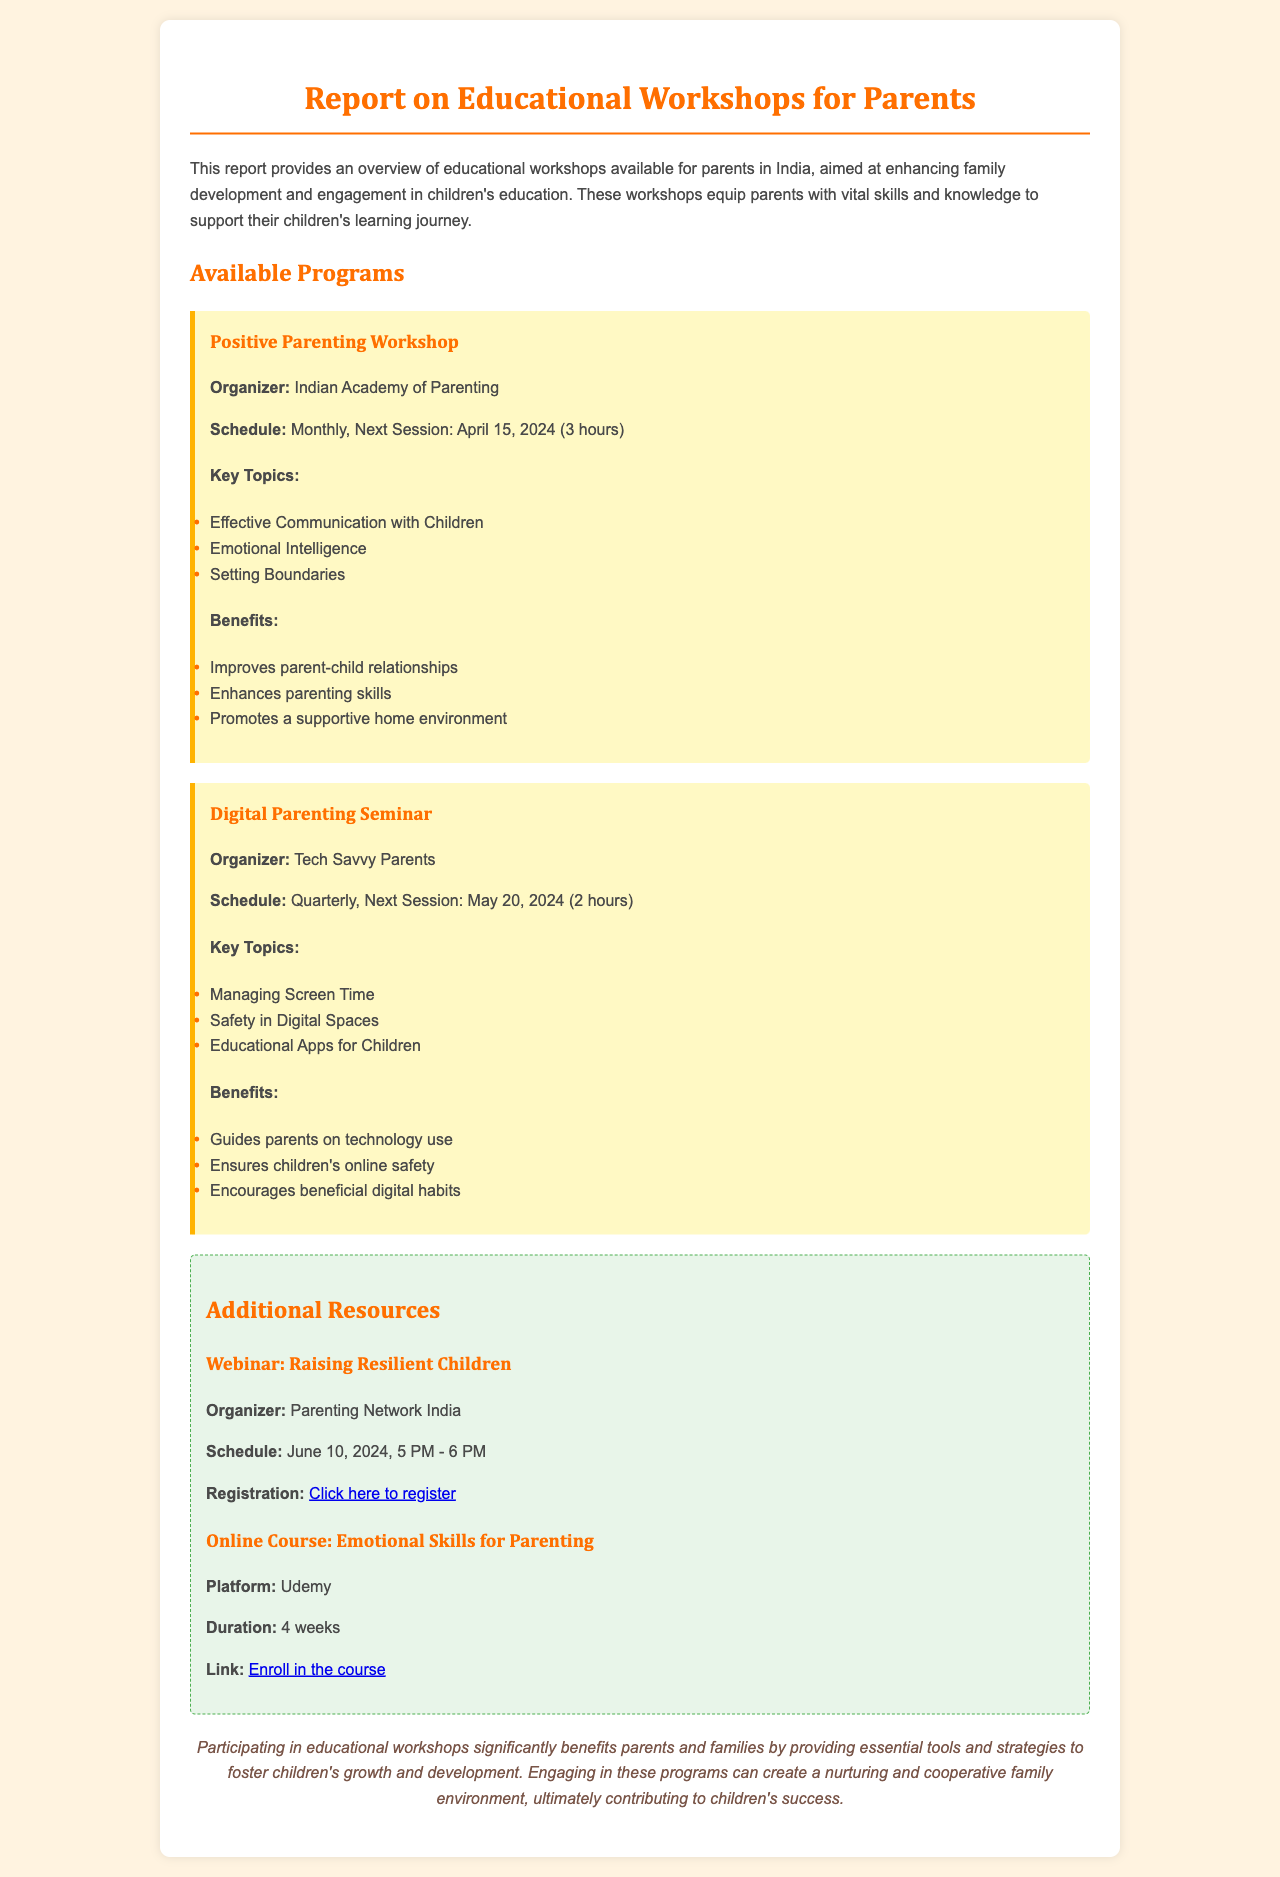what is the name of the workshop organized by the Indian Academy of Parenting? The name of the workshop is mentioned in the section detailing available programs, which is the Positive Parenting Workshop.
Answer: Positive Parenting Workshop when is the next session of the Digital Parenting Seminar? This information is found in the schedule section of the Digital Parenting Seminar, stating the next session date.
Answer: May 20, 2024 how long is the Positive Parenting Workshop? The duration of the workshop is specified in the schedule section of the Positive Parenting Workshop, indicating its length.
Answer: 3 hours what are the key topics covered in the Digital Parenting Seminar? The key topics are listed under the Digital Parenting Seminar's section, outlining the main subjects addressed in the seminar.
Answer: Managing Screen Time, Safety in Digital Spaces, Educational Apps for Children what is the registration link for the webinar "Raising Resilient Children"? The registration link is provided specifically for the webinar, detailing how parents can sign up for it.
Answer: https://parentingnetwork.in/webinar-resilient-children which online platform offers the course on Emotional Skills for Parenting? The platform that offers this course is indicated in the section describing the online course, specifying where parents can enroll.
Answer: Udemy what is a benefit of participating in educational workshops for parents? Benefits are outlined in various workshop sections, highlighting what families gain from these programs.
Answer: Improves parent-child relationships how often is the Positive Parenting Workshop held? This frequency is stated in the schedule information regarding the workshop's occurrence.
Answer: Monthly 